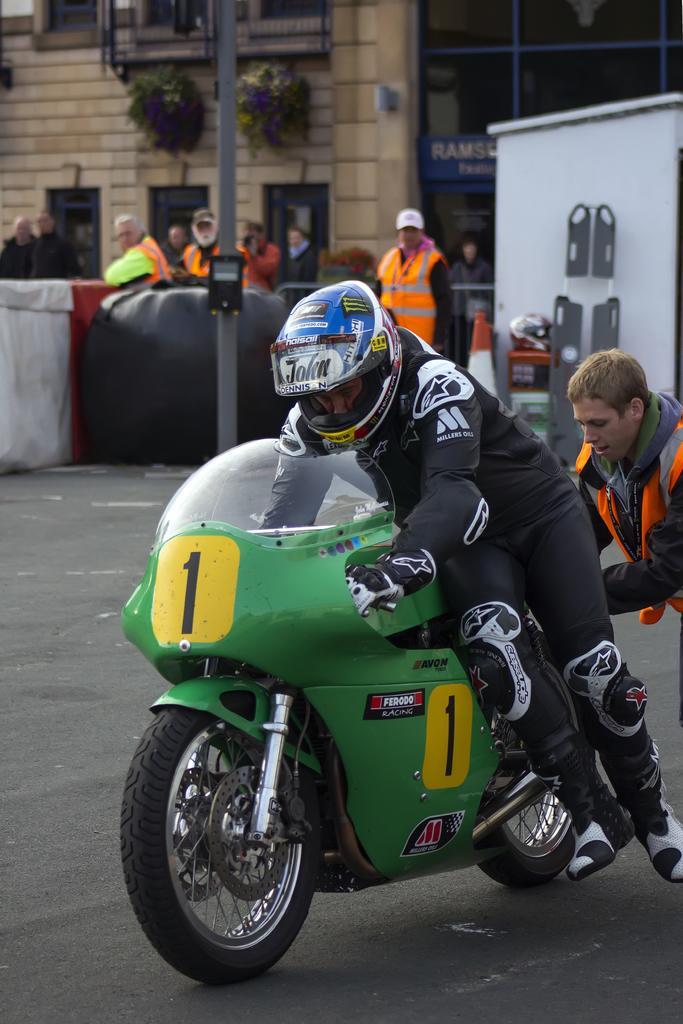In one or two sentences, can you explain what this image depicts? A man wearing helmets, gloves, knee pads is holding a racing bike. Behind him another person is standing. In the background there are many people standing wearing jackets. There are pillars, buildings, plants, walls and some cupboard. Also there is a traffic cone. 